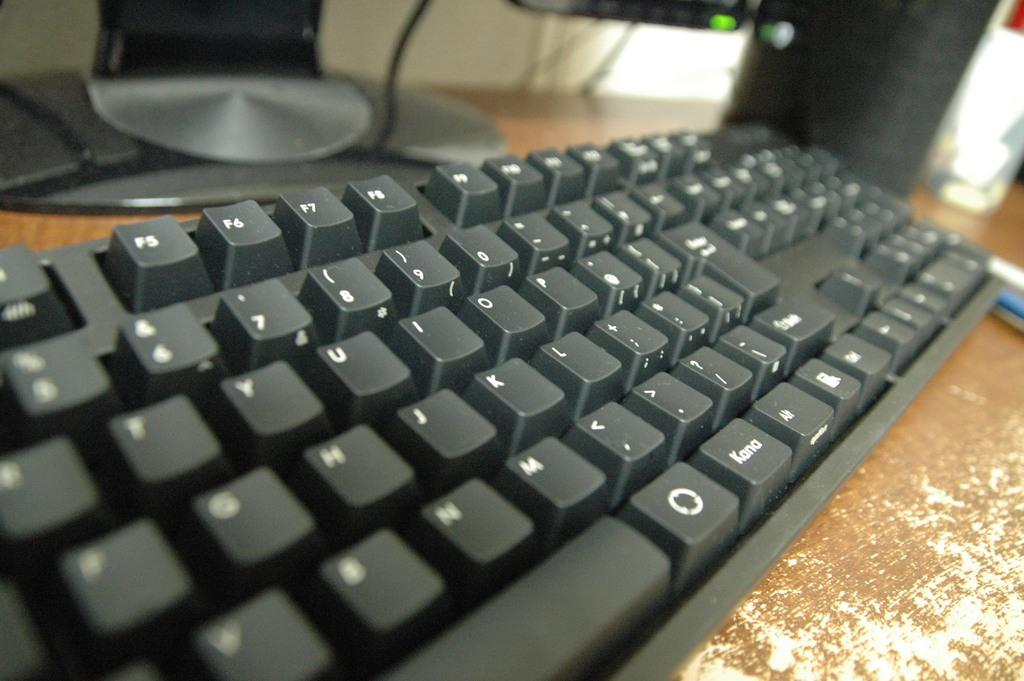<image>
Write a terse but informative summary of the picture. A dark grey keyboard with a Kana key on top of a desk 